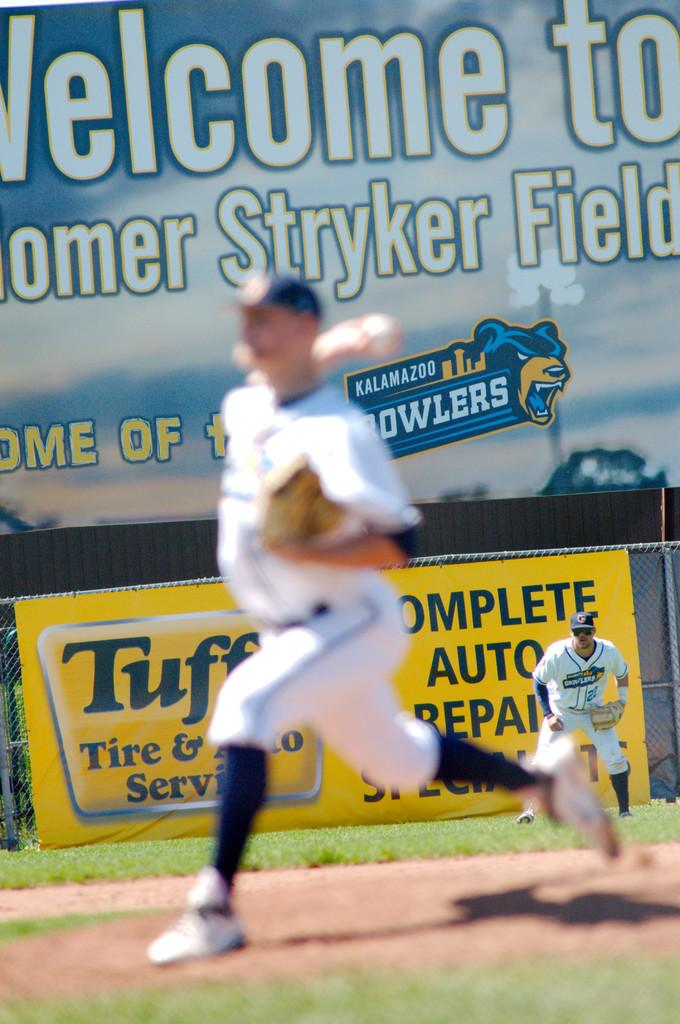<image>
Present a compact description of the photo's key features. A baseball player is running infront of a large Welcome sign 